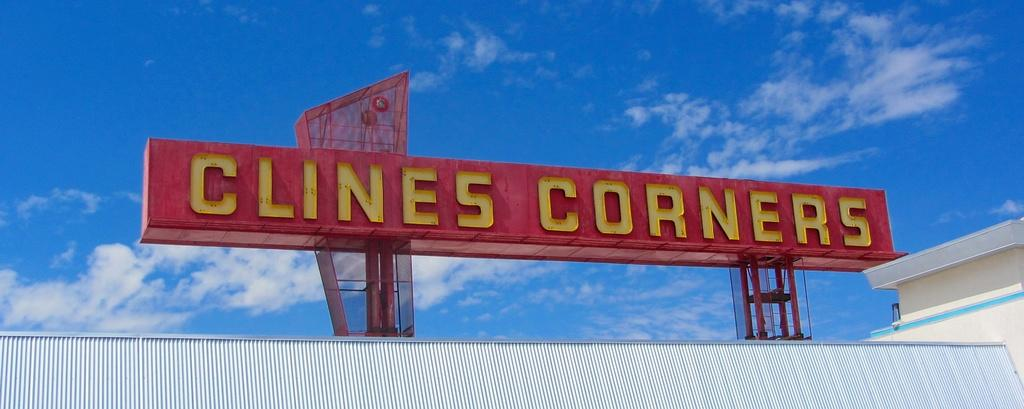<image>
Render a clear and concise summary of the photo. A red signpost for the Clines Corners diner. 